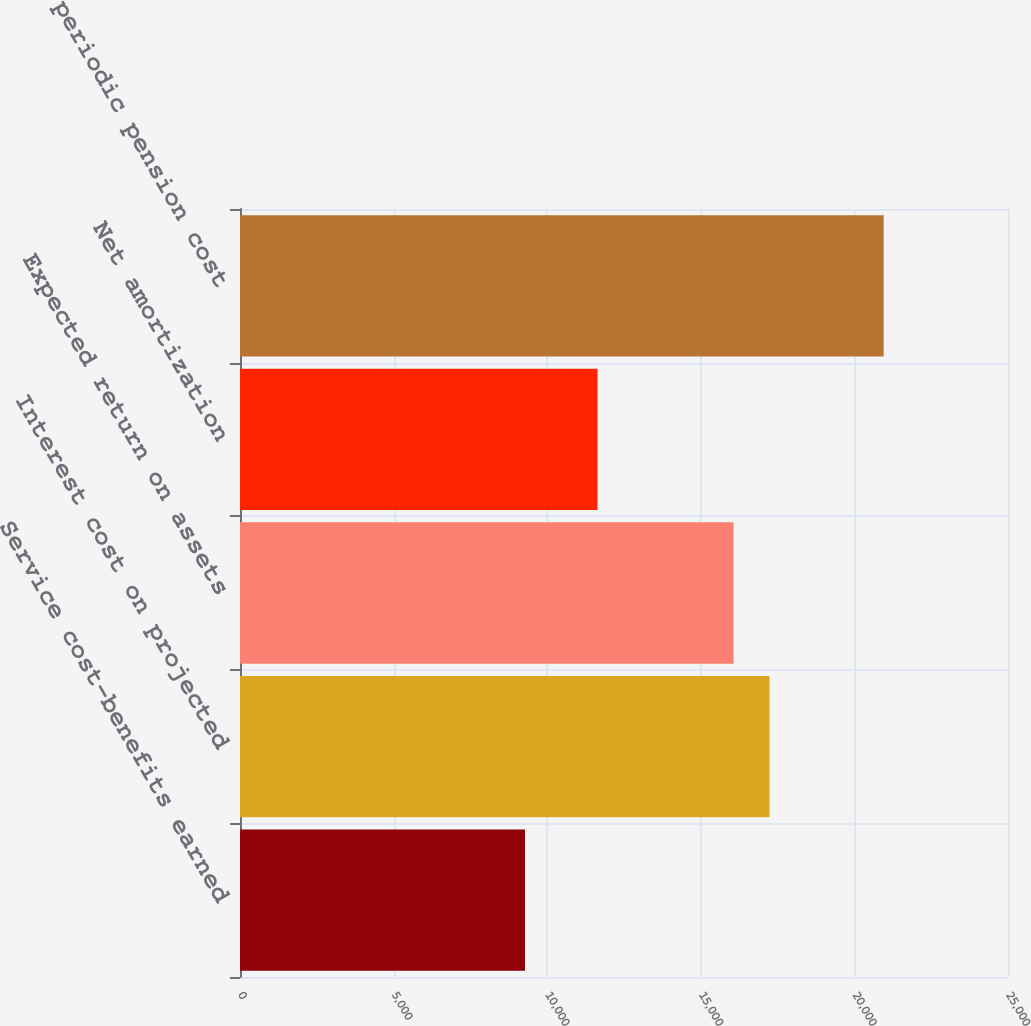Convert chart to OTSL. <chart><loc_0><loc_0><loc_500><loc_500><bar_chart><fcel>Service cost-benefits earned<fcel>Interest cost on projected<fcel>Expected return on assets<fcel>Net amortization<fcel>Net periodic pension cost<nl><fcel>9277<fcel>17235.5<fcel>16068<fcel>11637<fcel>20952<nl></chart> 